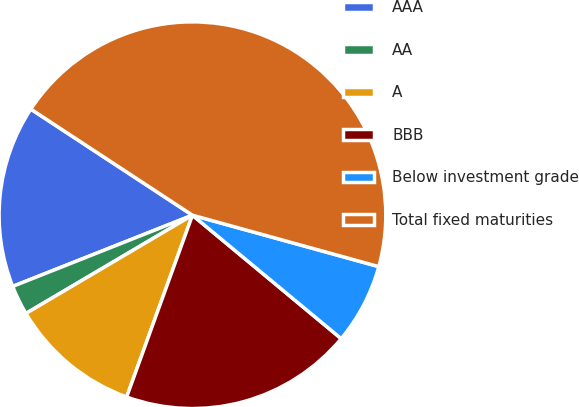Convert chart. <chart><loc_0><loc_0><loc_500><loc_500><pie_chart><fcel>AAA<fcel>AA<fcel>A<fcel>BBB<fcel>Below investment grade<fcel>Total fixed maturities<nl><fcel>15.25%<fcel>2.48%<fcel>10.99%<fcel>19.5%<fcel>6.74%<fcel>45.04%<nl></chart> 